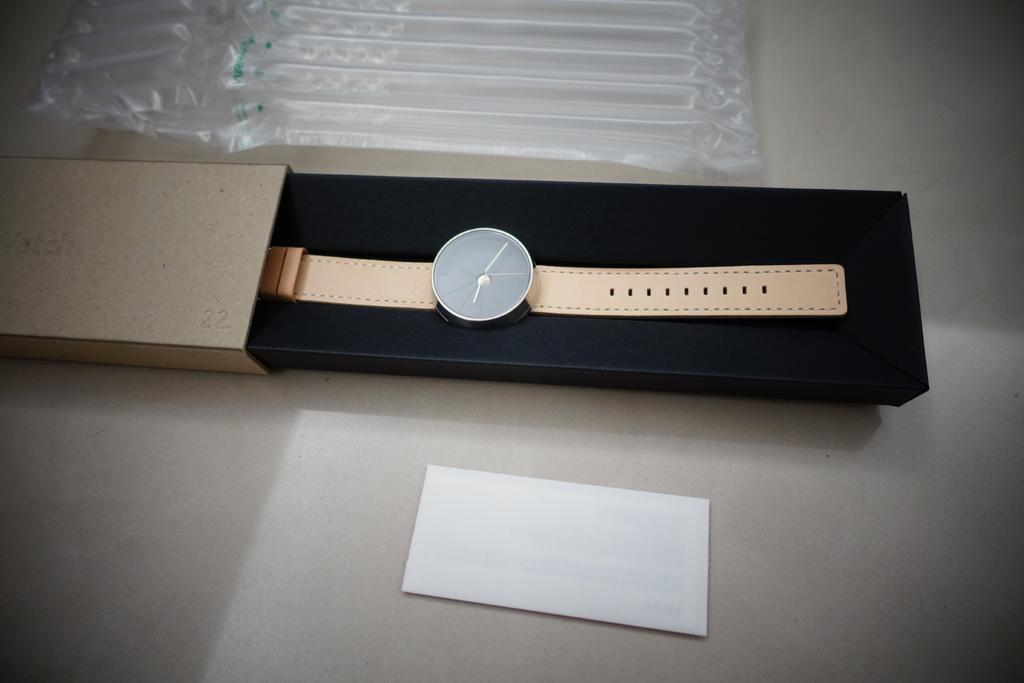What object is inside the box in the image? There is a wristwatch in the box in the image. What else can be seen in the image besides the wristwatch? There is a paper and a plastic cover visible in the image. What is the color of the surface in the image? The surface in the image is white colored. What type of shirt is being worn by the wristwatch in the image? There is no shirt present in the image, as the wristwatch is in a box and not being worn by anyone. 